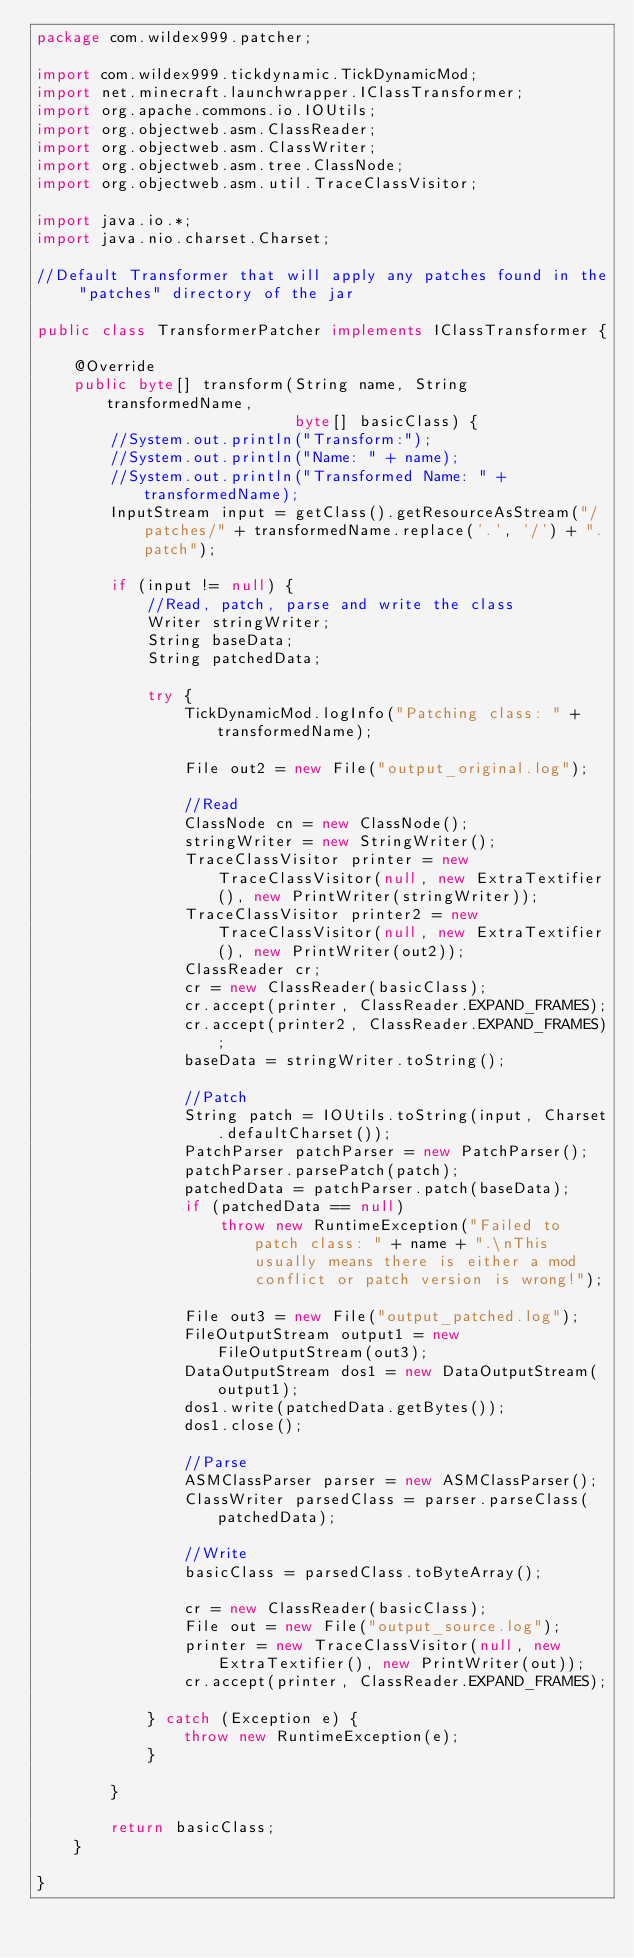Convert code to text. <code><loc_0><loc_0><loc_500><loc_500><_Java_>package com.wildex999.patcher;

import com.wildex999.tickdynamic.TickDynamicMod;
import net.minecraft.launchwrapper.IClassTransformer;
import org.apache.commons.io.IOUtils;
import org.objectweb.asm.ClassReader;
import org.objectweb.asm.ClassWriter;
import org.objectweb.asm.tree.ClassNode;
import org.objectweb.asm.util.TraceClassVisitor;

import java.io.*;
import java.nio.charset.Charset;

//Default Transformer that will apply any patches found in the "patches" directory of the jar

public class TransformerPatcher implements IClassTransformer {

	@Override
	public byte[] transform(String name, String transformedName,
	                        byte[] basicClass) {
		//System.out.println("Transform:");
		//System.out.println("Name: " + name);
		//System.out.println("Transformed Name: " + transformedName);
		InputStream input = getClass().getResourceAsStream("/patches/" + transformedName.replace('.', '/') + ".patch");

		if (input != null) {
			//Read, patch, parse and write the class
			Writer stringWriter;
			String baseData;
			String patchedData;

			try {
				TickDynamicMod.logInfo("Patching class: " + transformedName);

				File out2 = new File("output_original.log");

				//Read
				ClassNode cn = new ClassNode();
				stringWriter = new StringWriter();
				TraceClassVisitor printer = new TraceClassVisitor(null, new ExtraTextifier(), new PrintWriter(stringWriter));
				TraceClassVisitor printer2 = new TraceClassVisitor(null, new ExtraTextifier(), new PrintWriter(out2));
				ClassReader cr;
				cr = new ClassReader(basicClass);
				cr.accept(printer, ClassReader.EXPAND_FRAMES);
				cr.accept(printer2, ClassReader.EXPAND_FRAMES);
				baseData = stringWriter.toString();

				//Patch
				String patch = IOUtils.toString(input, Charset.defaultCharset());
				PatchParser patchParser = new PatchParser();
				patchParser.parsePatch(patch);
				patchedData = patchParser.patch(baseData);
				if (patchedData == null)
					throw new RuntimeException("Failed to patch class: " + name + ".\nThis usually means there is either a mod conflict or patch version is wrong!");

				File out3 = new File("output_patched.log");
				FileOutputStream output1 = new FileOutputStream(out3);
				DataOutputStream dos1 = new DataOutputStream(output1);
				dos1.write(patchedData.getBytes());
				dos1.close();

				//Parse
				ASMClassParser parser = new ASMClassParser();
				ClassWriter parsedClass = parser.parseClass(patchedData);

				//Write
				basicClass = parsedClass.toByteArray();

				cr = new ClassReader(basicClass);
				File out = new File("output_source.log");
				printer = new TraceClassVisitor(null, new ExtraTextifier(), new PrintWriter(out));
				cr.accept(printer, ClassReader.EXPAND_FRAMES);

			} catch (Exception e) {
				throw new RuntimeException(e);
			}

		}

		return basicClass;
	}

}
</code> 